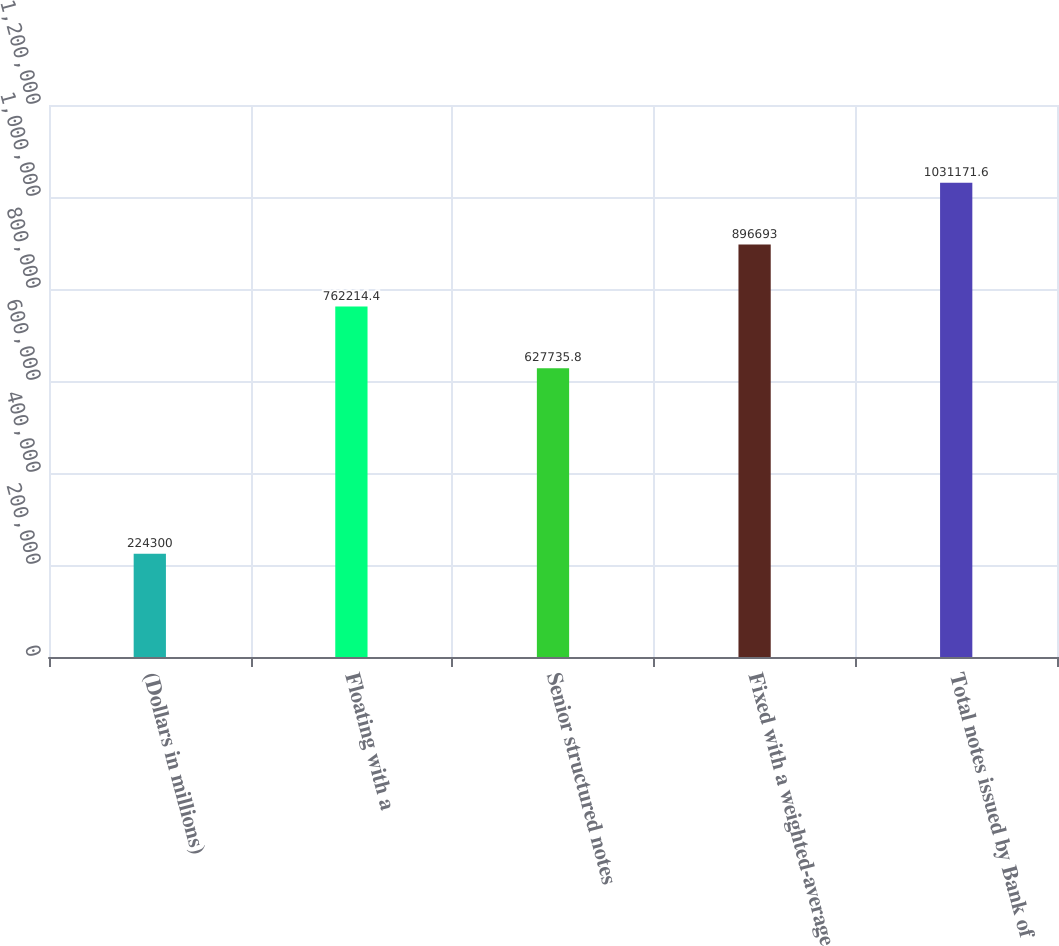Convert chart to OTSL. <chart><loc_0><loc_0><loc_500><loc_500><bar_chart><fcel>(Dollars in millions)<fcel>Floating with a<fcel>Senior structured notes<fcel>Fixed with a weighted-average<fcel>Total notes issued by Bank of<nl><fcel>224300<fcel>762214<fcel>627736<fcel>896693<fcel>1.03117e+06<nl></chart> 